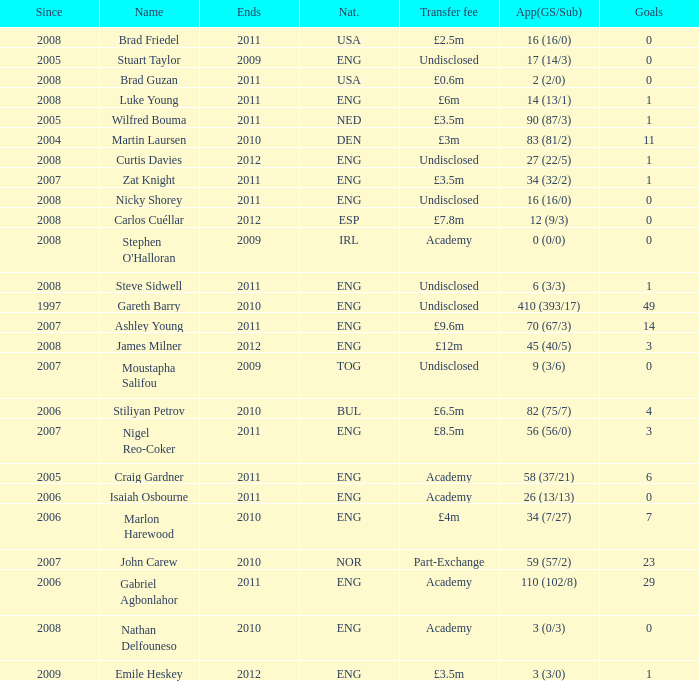When the transfer fee is £8.5m, what is the total ends? 2011.0. 